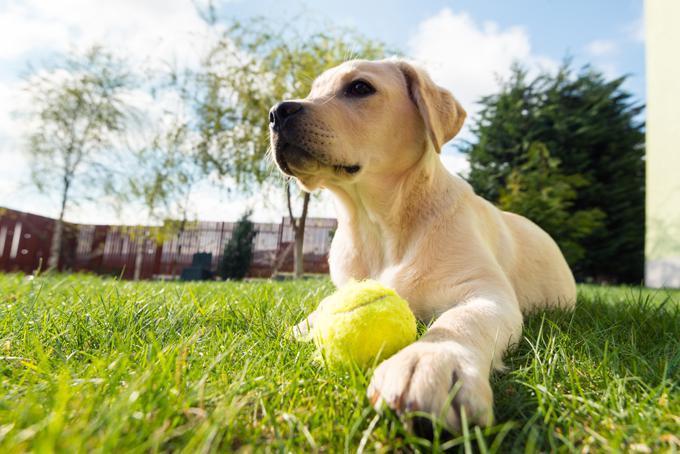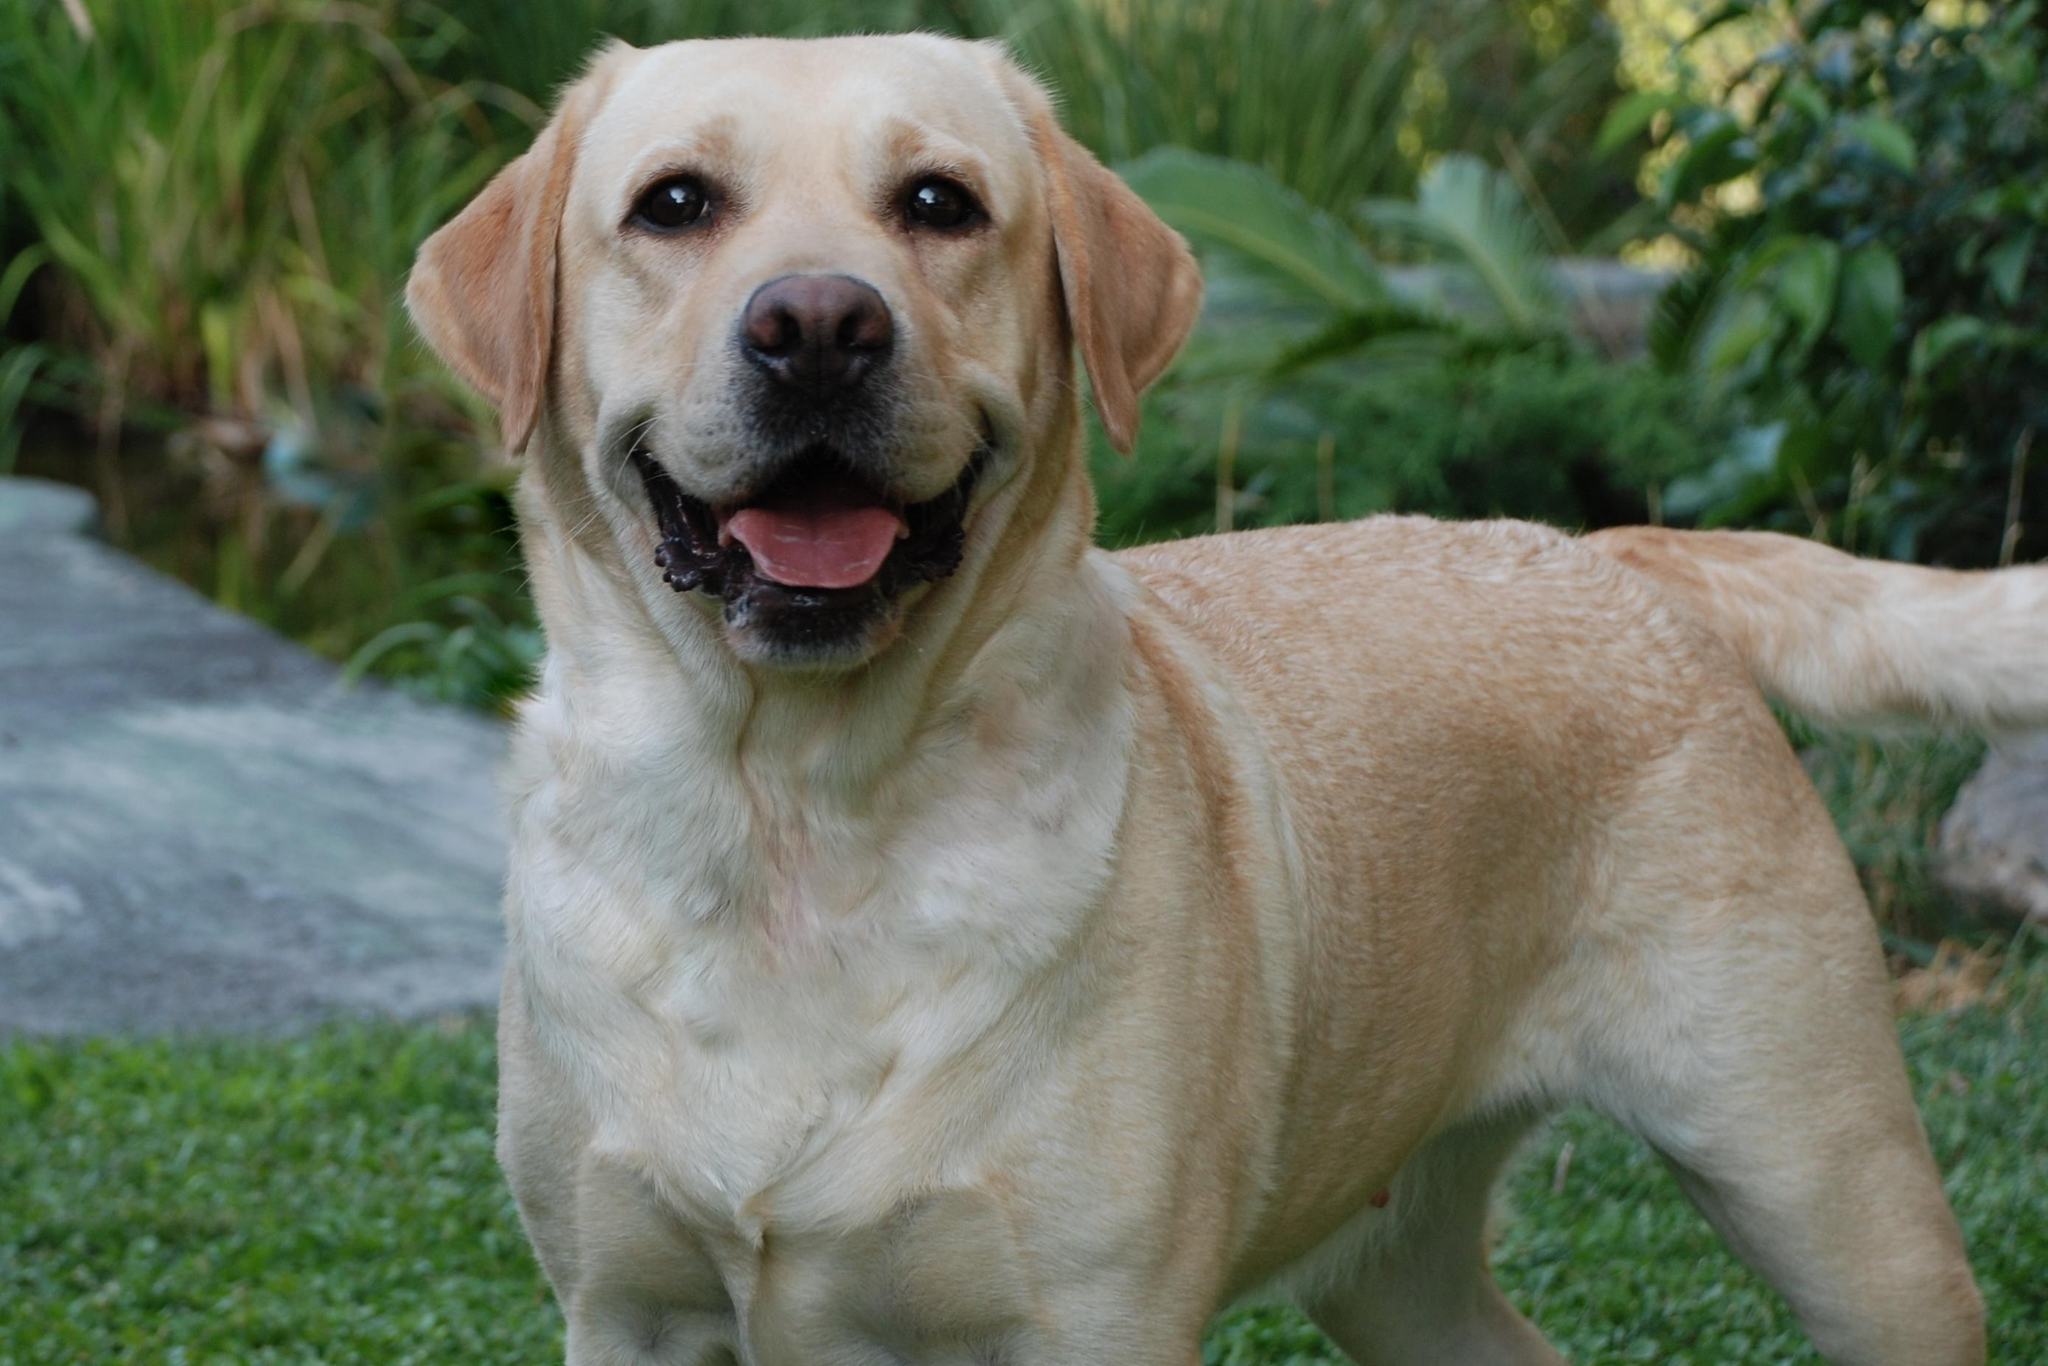The first image is the image on the left, the second image is the image on the right. Analyze the images presented: Is the assertion "An image shows a puppy with tongue showing and something in its mouth." valid? Answer yes or no. No. The first image is the image on the left, the second image is the image on the right. Given the left and right images, does the statement "The dog in the grass in the image on the left has something to play with." hold true? Answer yes or no. Yes. 